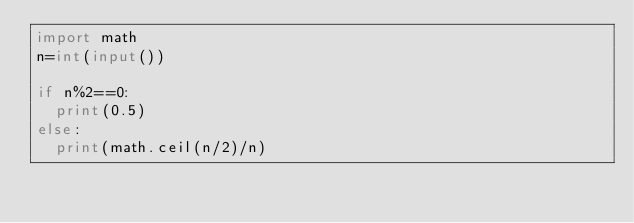Convert code to text. <code><loc_0><loc_0><loc_500><loc_500><_Python_>import math
n=int(input())

if n%2==0:
  print(0.5)
else:
  print(math.ceil(n/2)/n)</code> 